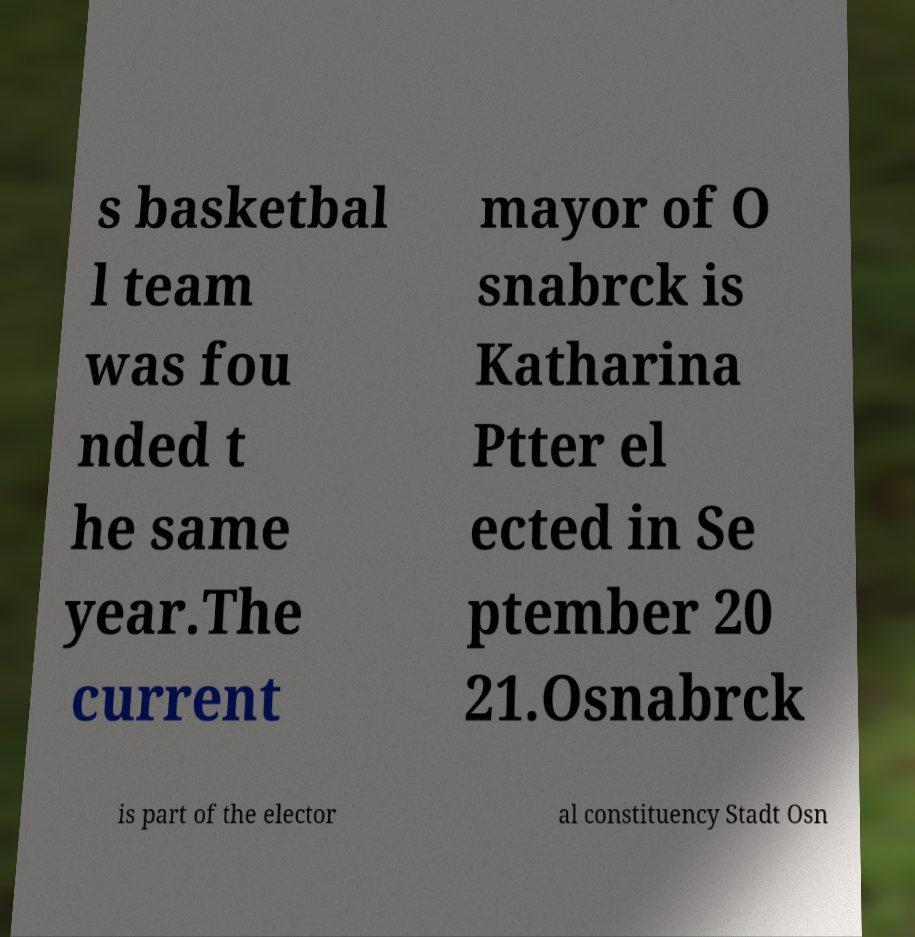Could you extract and type out the text from this image? s basketbal l team was fou nded t he same year.The current mayor of O snabrck is Katharina Ptter el ected in Se ptember 20 21.Osnabrck is part of the elector al constituency Stadt Osn 